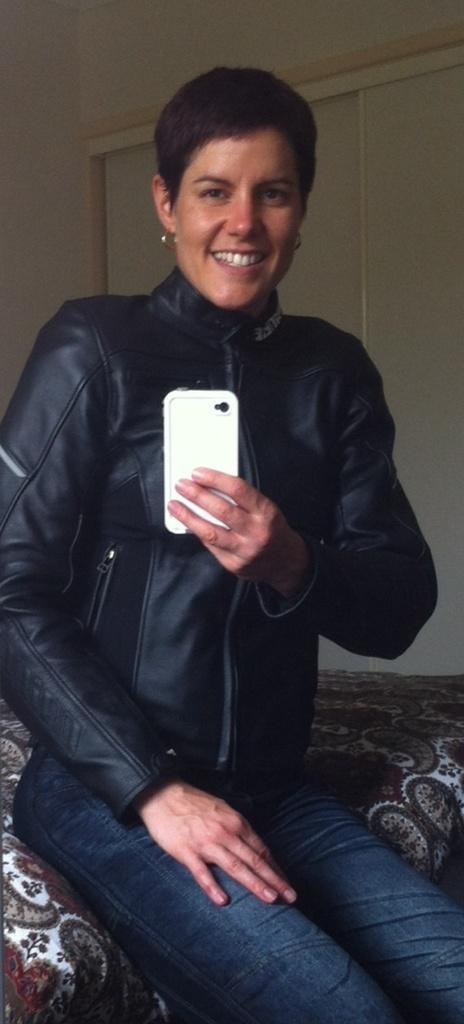Can you describe this image briefly? In this image there is a woman sitting in a bed and taking a picture by a mobile phone , and the back ground there is a wall. 